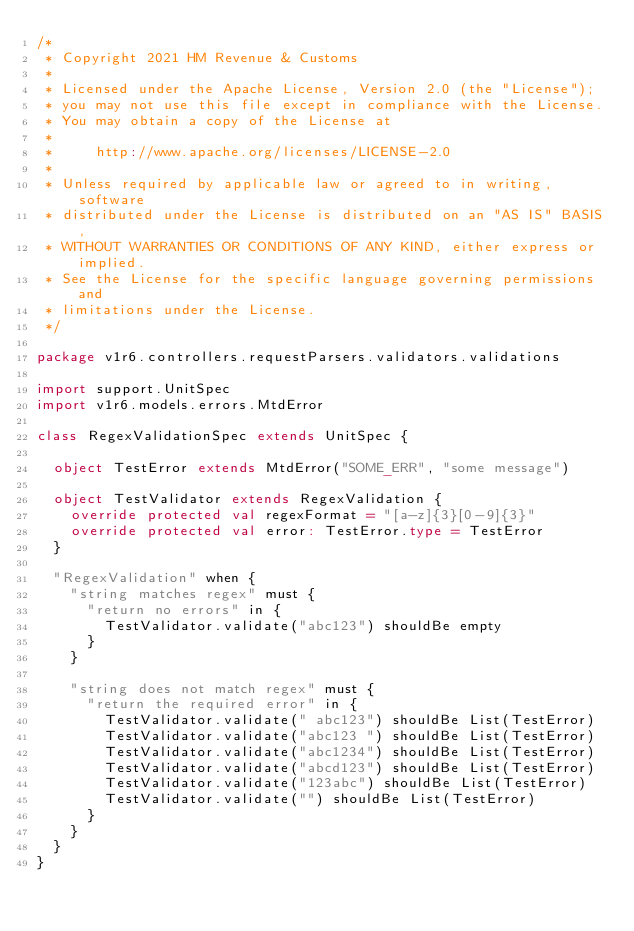<code> <loc_0><loc_0><loc_500><loc_500><_Scala_>/*
 * Copyright 2021 HM Revenue & Customs
 *
 * Licensed under the Apache License, Version 2.0 (the "License");
 * you may not use this file except in compliance with the License.
 * You may obtain a copy of the License at
 *
 *     http://www.apache.org/licenses/LICENSE-2.0
 *
 * Unless required by applicable law or agreed to in writing, software
 * distributed under the License is distributed on an "AS IS" BASIS,
 * WITHOUT WARRANTIES OR CONDITIONS OF ANY KIND, either express or implied.
 * See the License for the specific language governing permissions and
 * limitations under the License.
 */

package v1r6.controllers.requestParsers.validators.validations

import support.UnitSpec
import v1r6.models.errors.MtdError

class RegexValidationSpec extends UnitSpec {

  object TestError extends MtdError("SOME_ERR", "some message")

  object TestValidator extends RegexValidation {
    override protected val regexFormat = "[a-z]{3}[0-9]{3}"
    override protected val error: TestError.type = TestError
  }

  "RegexValidation" when {
    "string matches regex" must {
      "return no errors" in {
        TestValidator.validate("abc123") shouldBe empty
      }
    }

    "string does not match regex" must {
      "return the required error" in {
        TestValidator.validate(" abc123") shouldBe List(TestError)
        TestValidator.validate("abc123 ") shouldBe List(TestError)
        TestValidator.validate("abc1234") shouldBe List(TestError)
        TestValidator.validate("abcd123") shouldBe List(TestError)
        TestValidator.validate("123abc") shouldBe List(TestError)
        TestValidator.validate("") shouldBe List(TestError)
      }
    }
  }
}
</code> 